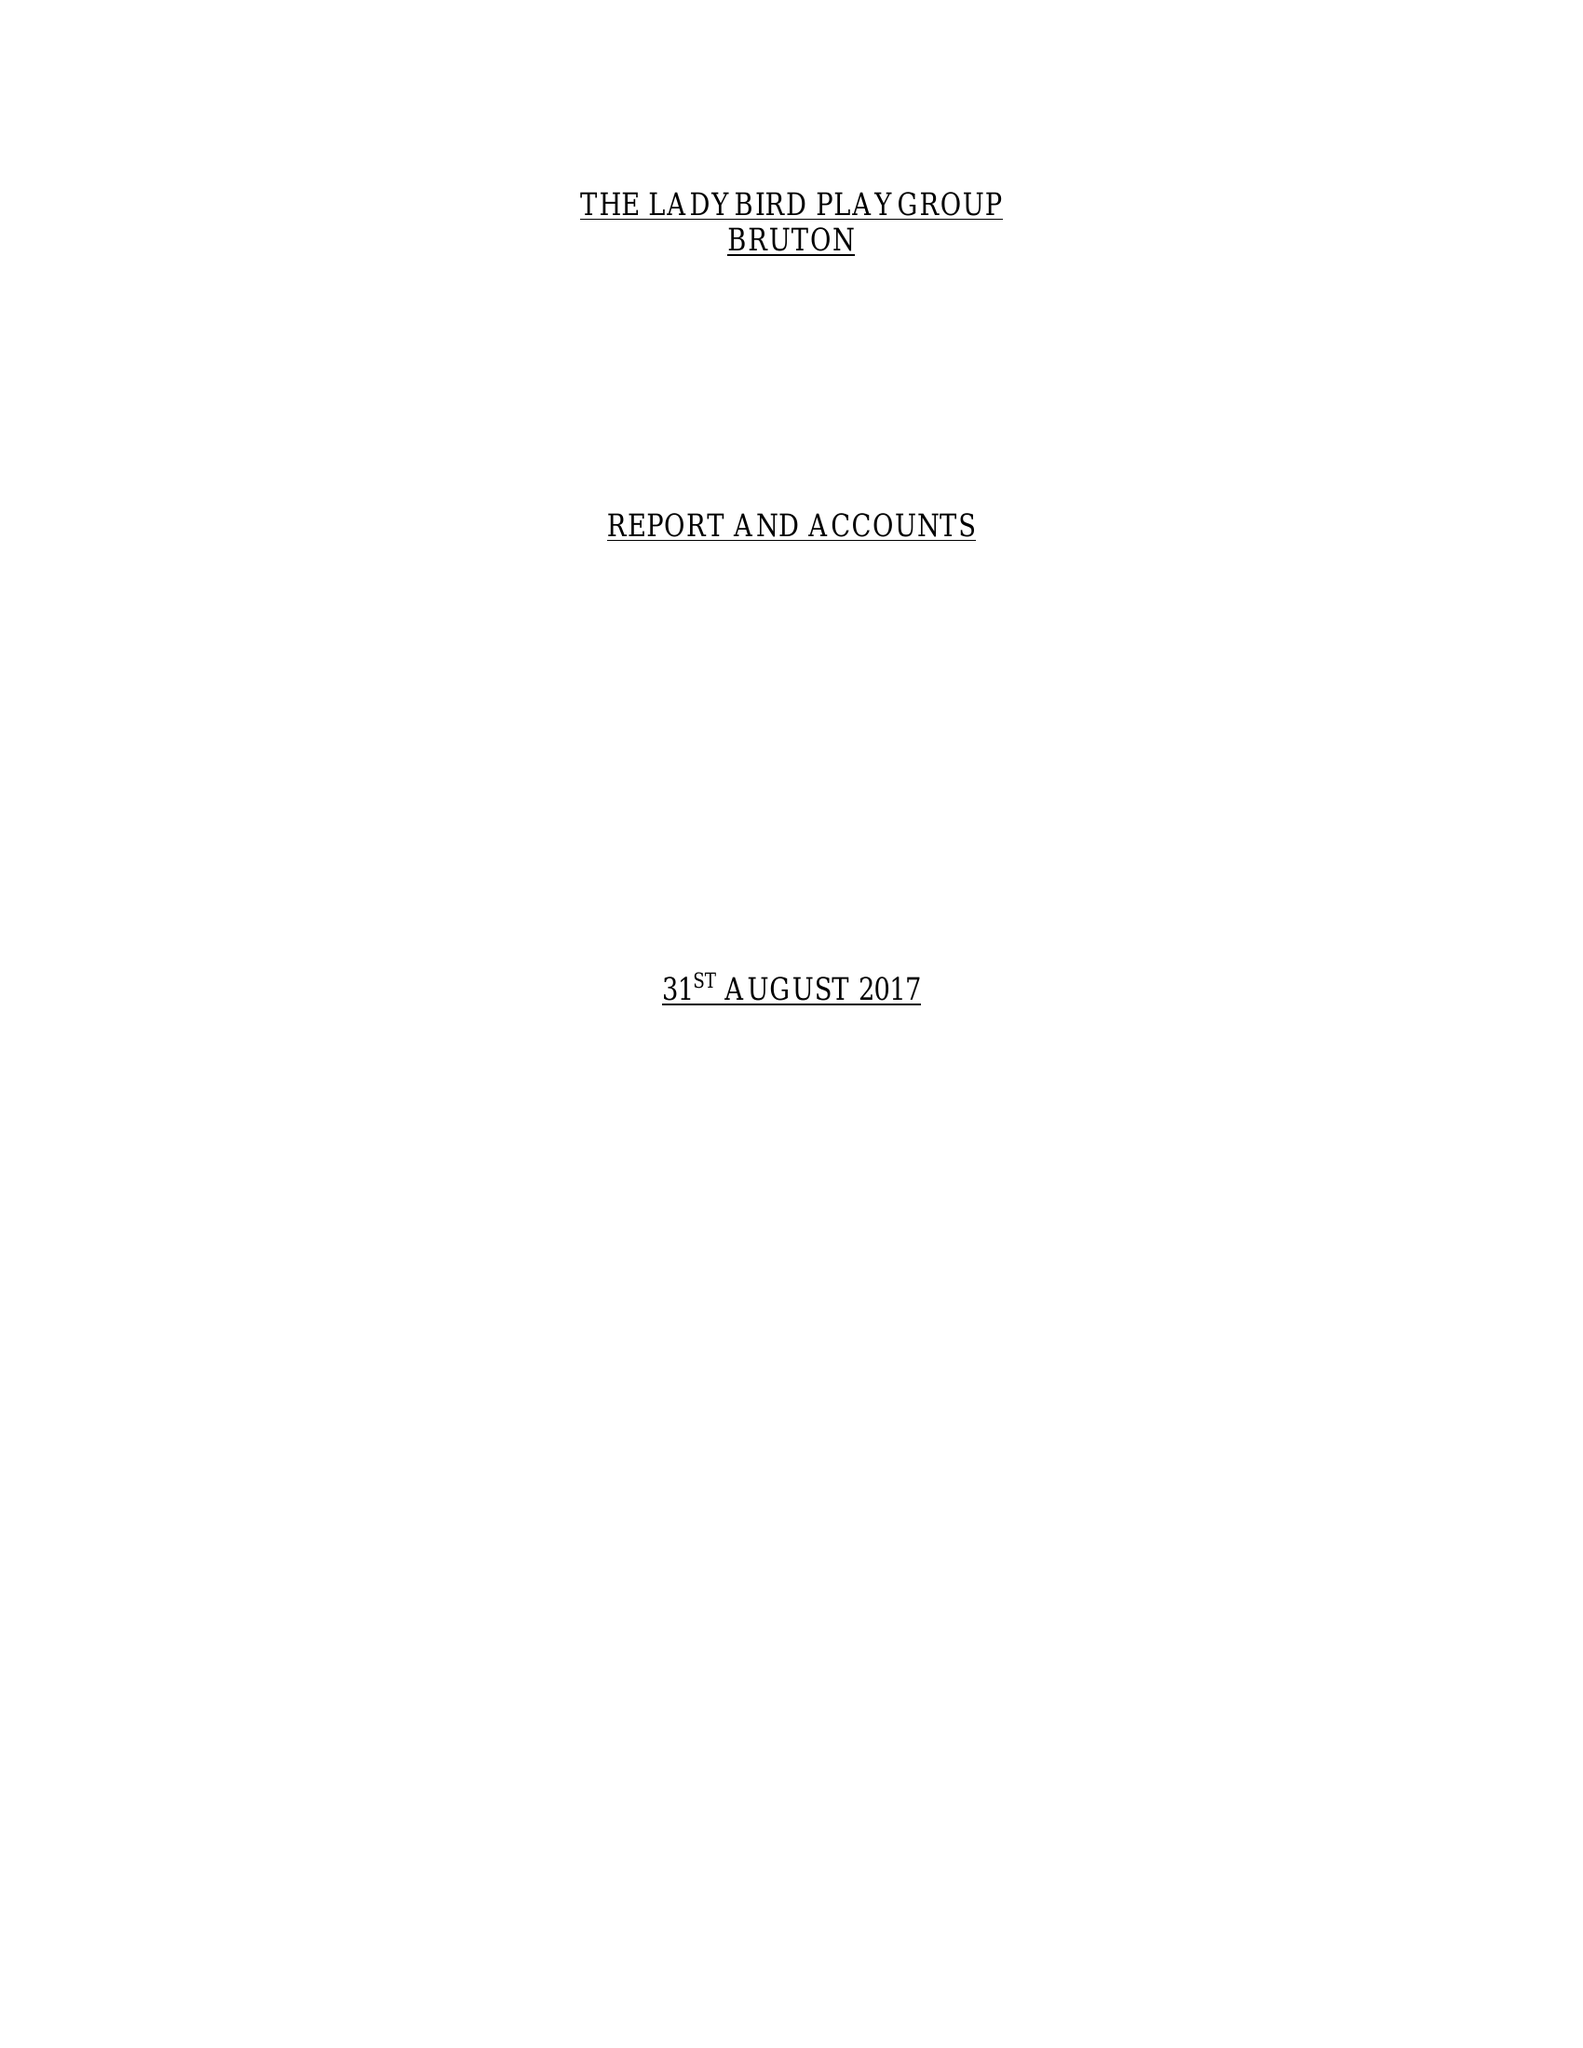What is the value for the spending_annually_in_british_pounds?
Answer the question using a single word or phrase. 53287.00 